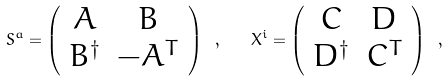<formula> <loc_0><loc_0><loc_500><loc_500>S ^ { a } = \left ( \begin{array} { c c } { A } & { B } \\ { B ^ { \dagger } } & - { A } ^ { T } \end{array} \right ) \ , \quad X ^ { i } = \left ( \begin{array} { c c } { C } & { D } \\ { D ^ { \dagger } } & { C } ^ { T } \end{array} \right ) \ ,</formula> 